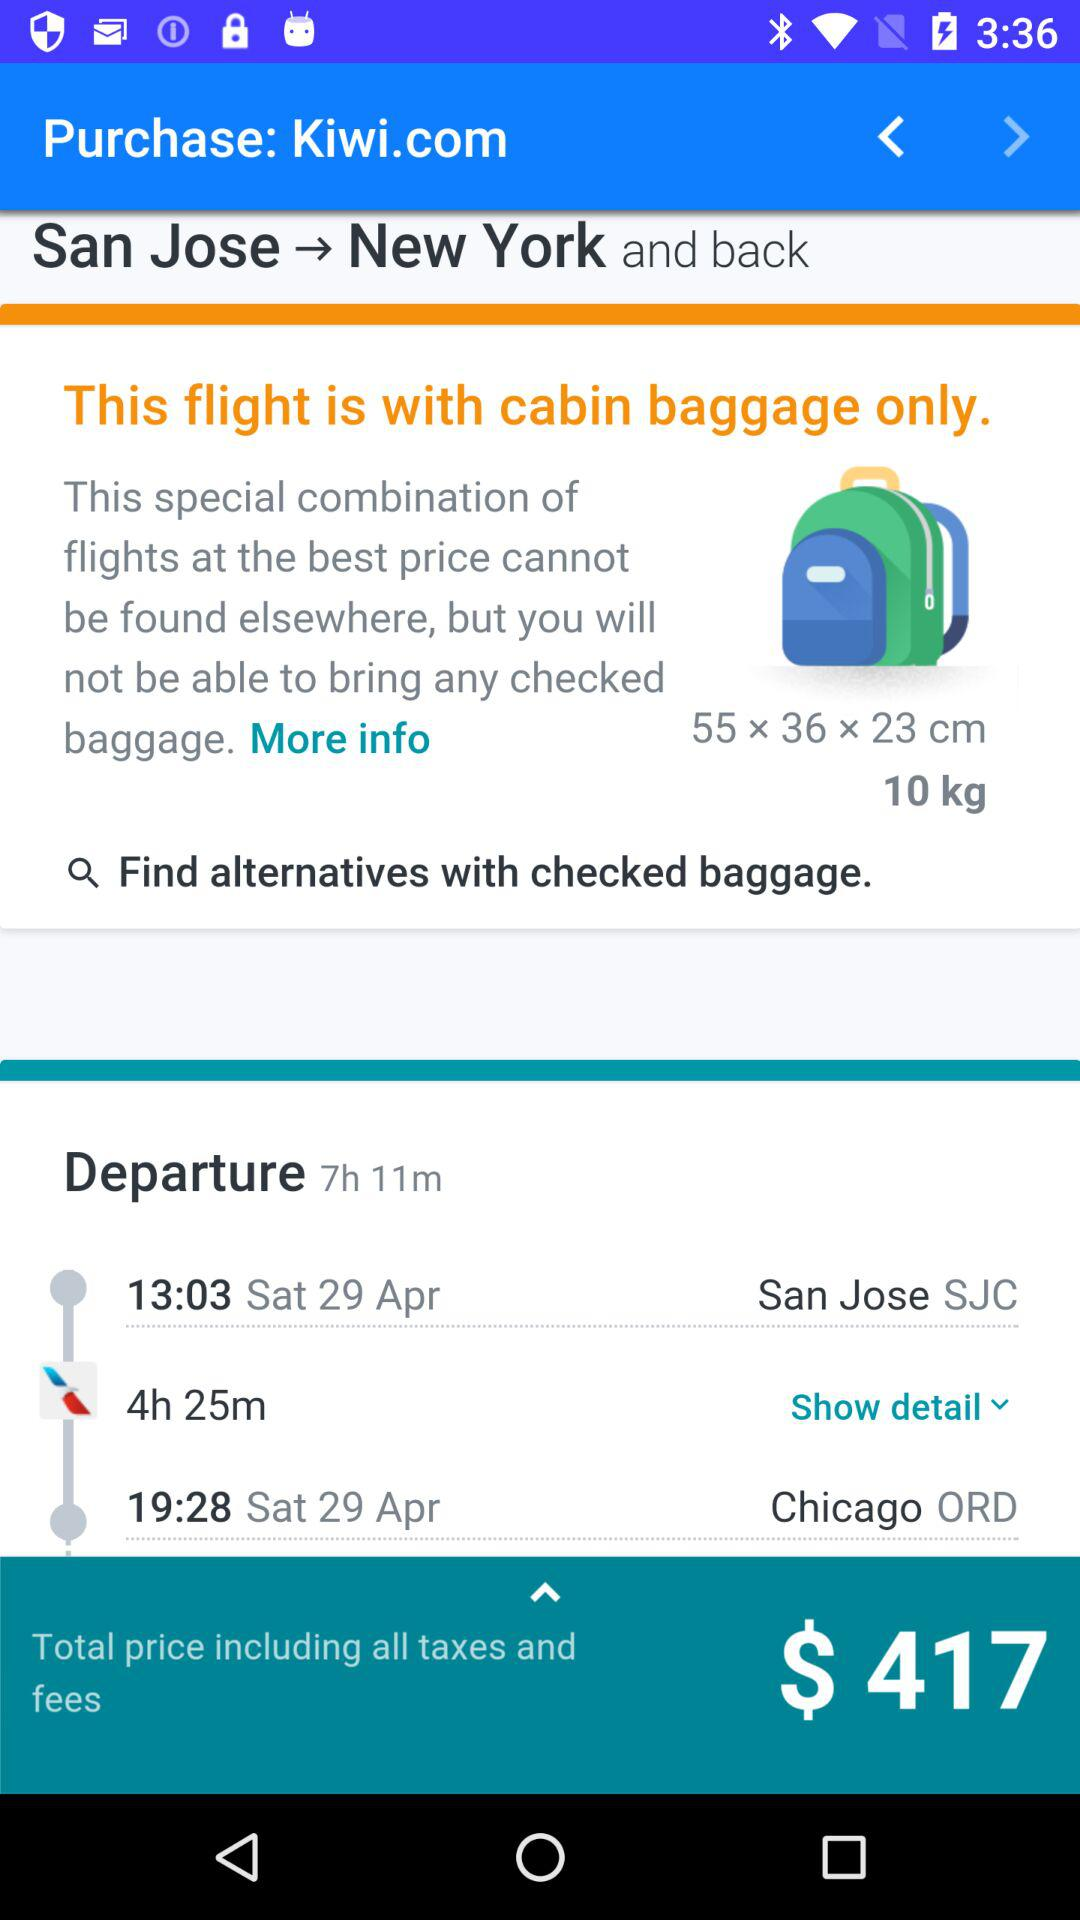What is the departure time? The departure time is 7 hours and 11 minutes. 